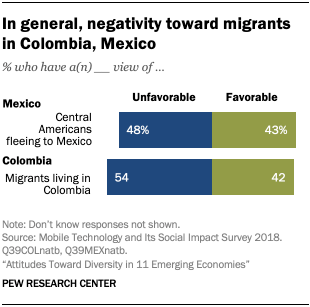Give some essential details in this illustration. The ratio of blue and green bars for "Migrants living in Colombia" is 0.379861111... Yes, only two colors are used to represent the bars in the given bar chart. 